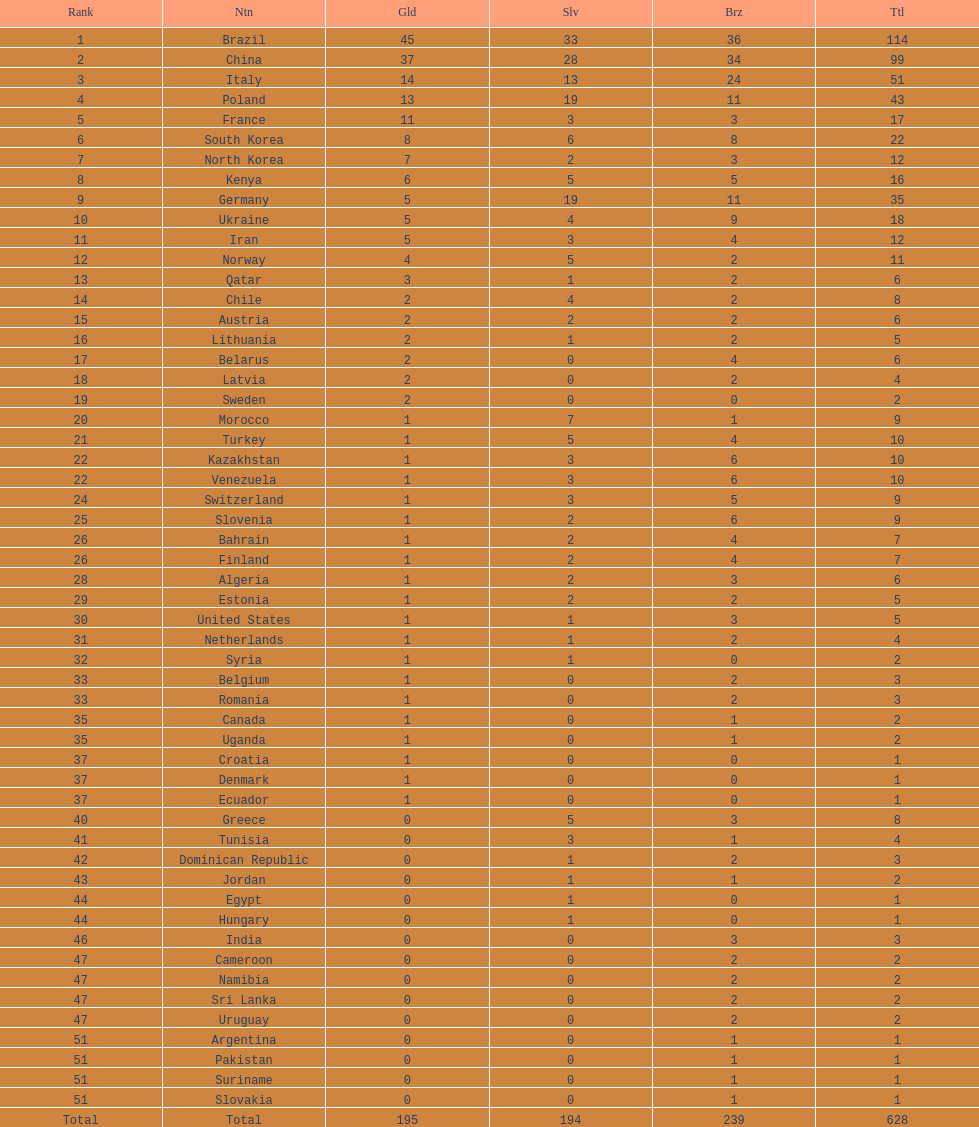Did italy or norway have 51 total medals? Italy. 